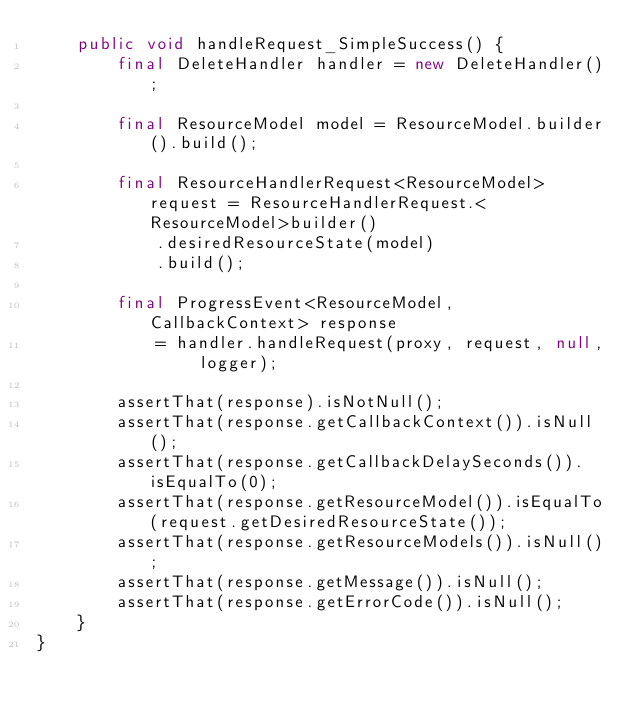<code> <loc_0><loc_0><loc_500><loc_500><_Java_>    public void handleRequest_SimpleSuccess() {
        final DeleteHandler handler = new DeleteHandler();

        final ResourceModel model = ResourceModel.builder().build();

        final ResourceHandlerRequest<ResourceModel> request = ResourceHandlerRequest.<ResourceModel>builder()
            .desiredResourceState(model)
            .build();

        final ProgressEvent<ResourceModel, CallbackContext> response
            = handler.handleRequest(proxy, request, null, logger);

        assertThat(response).isNotNull();
        assertThat(response.getCallbackContext()).isNull();
        assertThat(response.getCallbackDelaySeconds()).isEqualTo(0);
        assertThat(response.getResourceModel()).isEqualTo(request.getDesiredResourceState());
        assertThat(response.getResourceModels()).isNull();
        assertThat(response.getMessage()).isNull();
        assertThat(response.getErrorCode()).isNull();
    }
}
</code> 